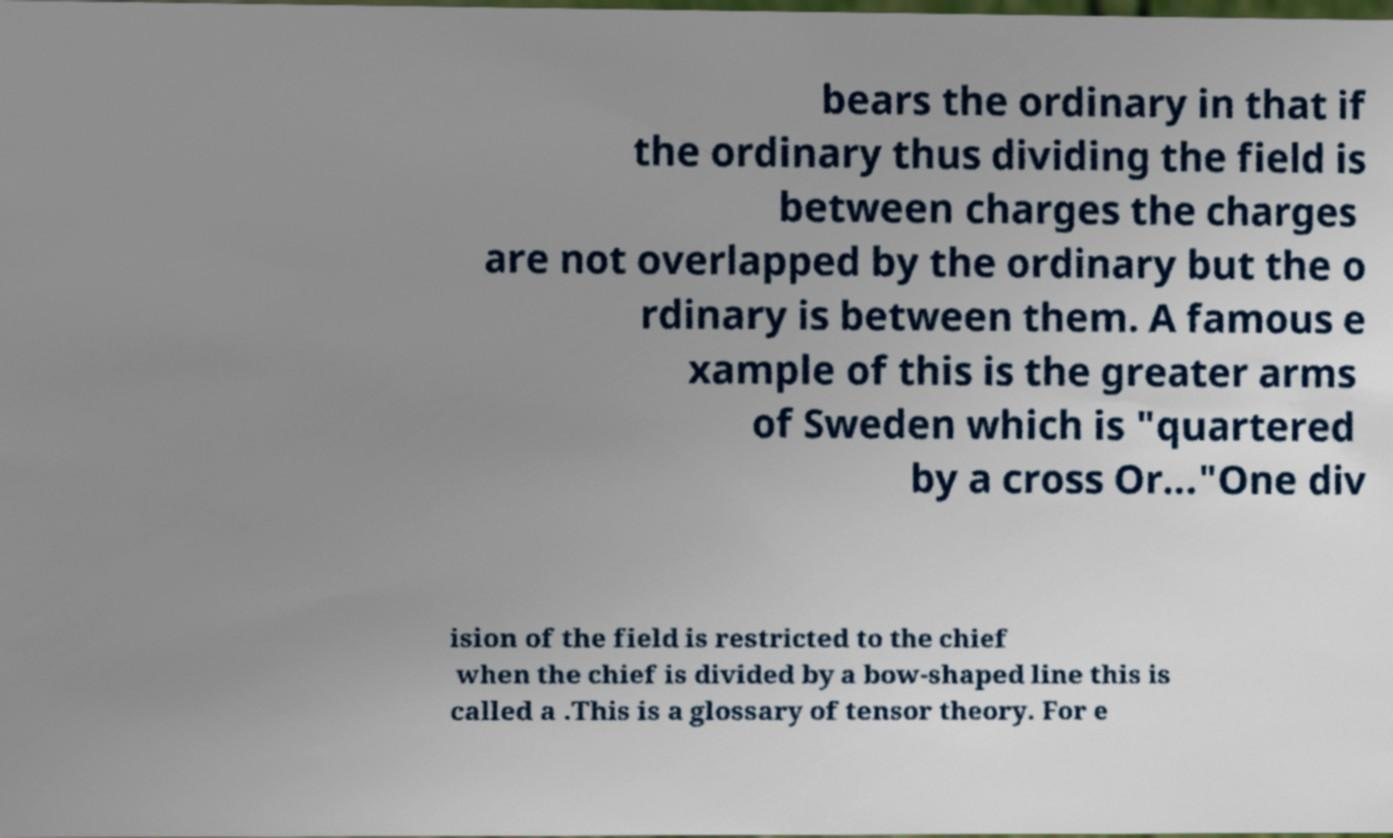Please identify and transcribe the text found in this image. bears the ordinary in that if the ordinary thus dividing the field is between charges the charges are not overlapped by the ordinary but the o rdinary is between them. A famous e xample of this is the greater arms of Sweden which is "quartered by a cross Or..."One div ision of the field is restricted to the chief when the chief is divided by a bow-shaped line this is called a .This is a glossary of tensor theory. For e 